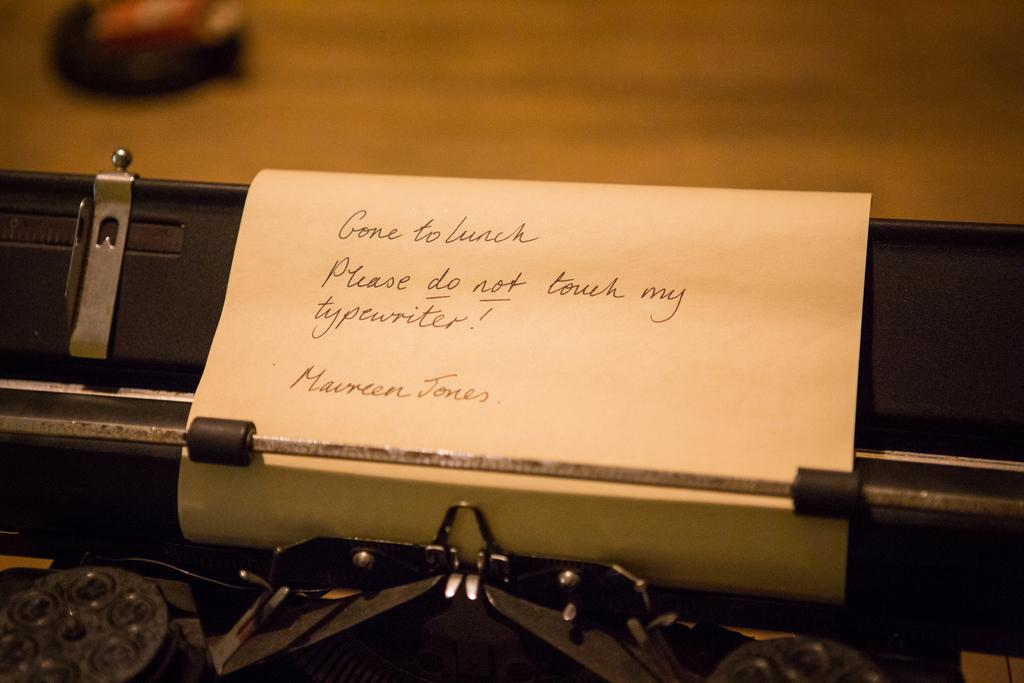What object in the image resembles a typewriter? There is an object that looks like a typewriter in the image. What is on the paper in the image? There is a paper with text on it in the image. Can you describe the background of the image? The background of the image is blurry. How many people are in the group that is trying to roll the quiet object in the image? There is no group, object being rolled, or quiet object present in the image. 